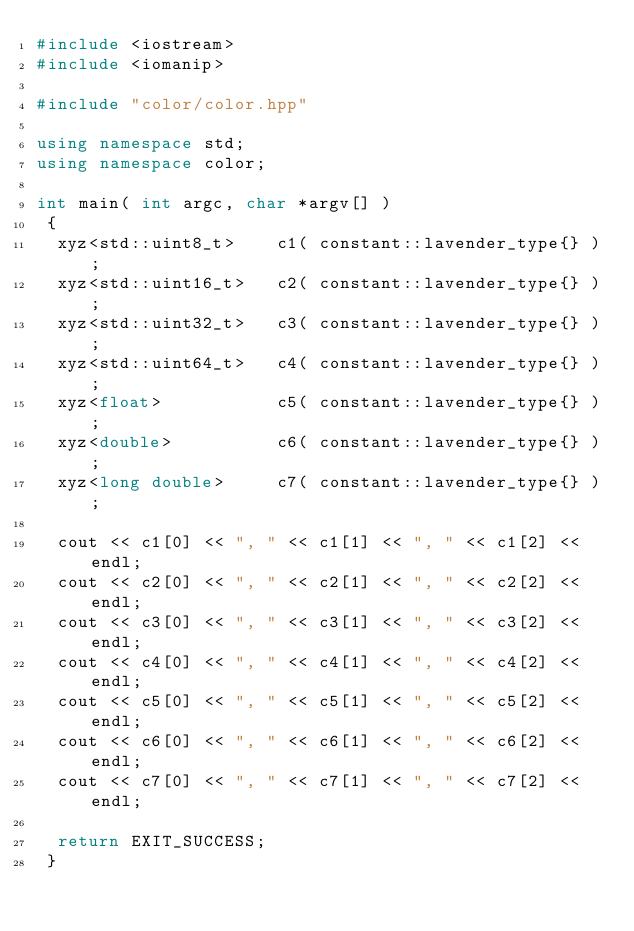Convert code to text. <code><loc_0><loc_0><loc_500><loc_500><_C++_>#include <iostream>
#include <iomanip>

#include "color/color.hpp"

using namespace std;
using namespace color;

int main( int argc, char *argv[] )
 {
  xyz<std::uint8_t>    c1( constant::lavender_type{} );
  xyz<std::uint16_t>   c2( constant::lavender_type{} );
  xyz<std::uint32_t>   c3( constant::lavender_type{} );
  xyz<std::uint64_t>   c4( constant::lavender_type{} );
  xyz<float>           c5( constant::lavender_type{} );
  xyz<double>          c6( constant::lavender_type{} );
  xyz<long double>     c7( constant::lavender_type{} );

  cout << c1[0] << ", " << c1[1] << ", " << c1[2] << endl;
  cout << c2[0] << ", " << c2[1] << ", " << c2[2] << endl;
  cout << c3[0] << ", " << c3[1] << ", " << c3[2] << endl;
  cout << c4[0] << ", " << c4[1] << ", " << c4[2] << endl;
  cout << c5[0] << ", " << c5[1] << ", " << c5[2] << endl;
  cout << c6[0] << ", " << c6[1] << ", " << c6[2] << endl;
  cout << c7[0] << ", " << c7[1] << ", " << c7[2] << endl;

  return EXIT_SUCCESS;
 }
</code> 